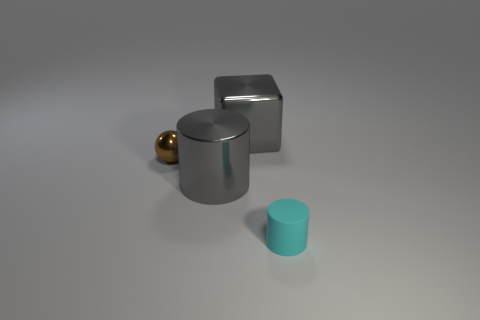Subtract all cyan blocks. Subtract all brown balls. How many blocks are left? 1 Add 1 brown balls. How many objects exist? 5 Subtract all cubes. How many objects are left? 3 Add 3 small brown metallic cylinders. How many small brown metallic cylinders exist? 3 Subtract 0 purple balls. How many objects are left? 4 Subtract all big cubes. Subtract all gray shiny cylinders. How many objects are left? 2 Add 3 tiny cyan things. How many tiny cyan things are left? 4 